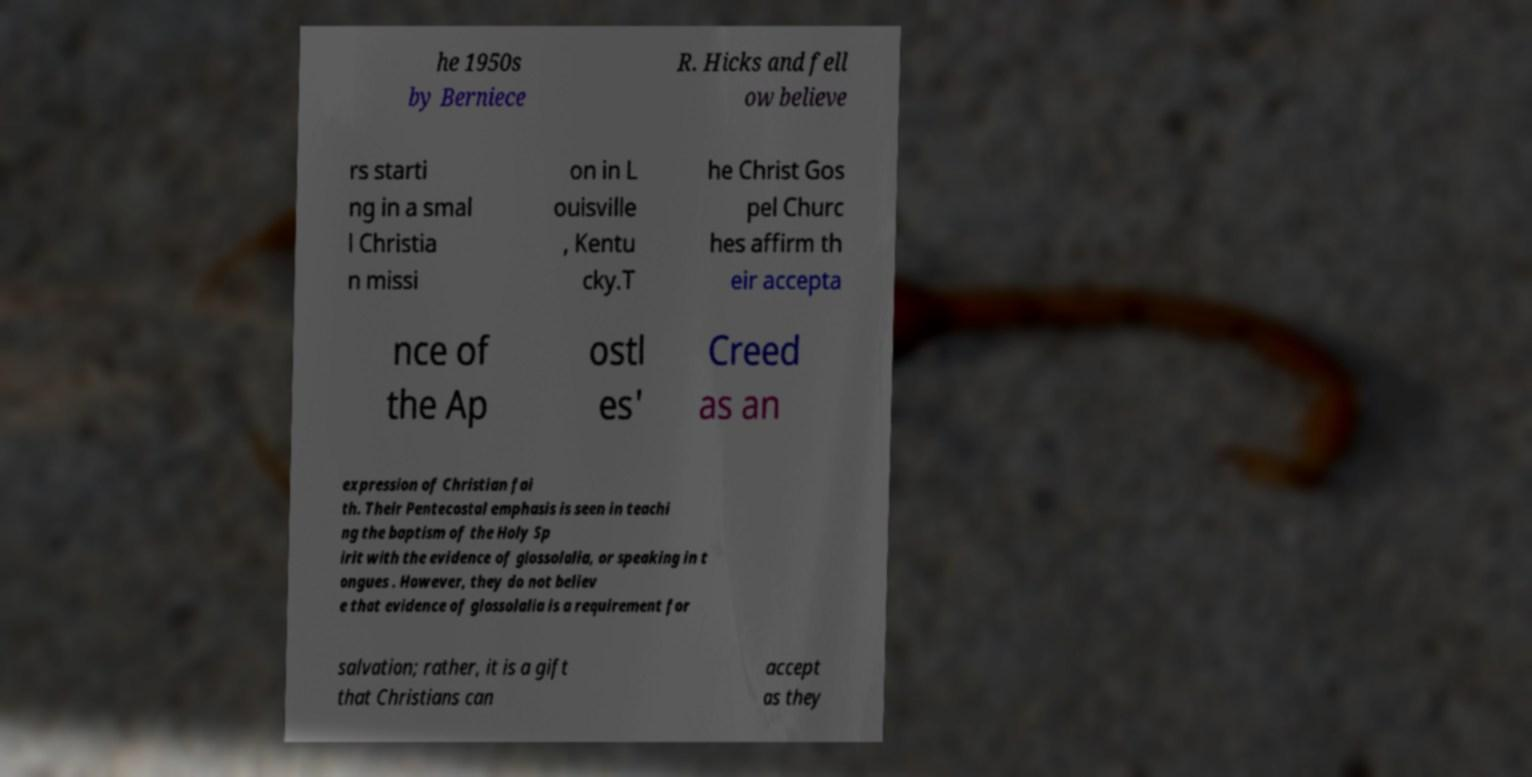Could you assist in decoding the text presented in this image and type it out clearly? he 1950s by Berniece R. Hicks and fell ow believe rs starti ng in a smal l Christia n missi on in L ouisville , Kentu cky.T he Christ Gos pel Churc hes affirm th eir accepta nce of the Ap ostl es' Creed as an expression of Christian fai th. Their Pentecostal emphasis is seen in teachi ng the baptism of the Holy Sp irit with the evidence of glossolalia, or speaking in t ongues . However, they do not believ e that evidence of glossolalia is a requirement for salvation; rather, it is a gift that Christians can accept as they 